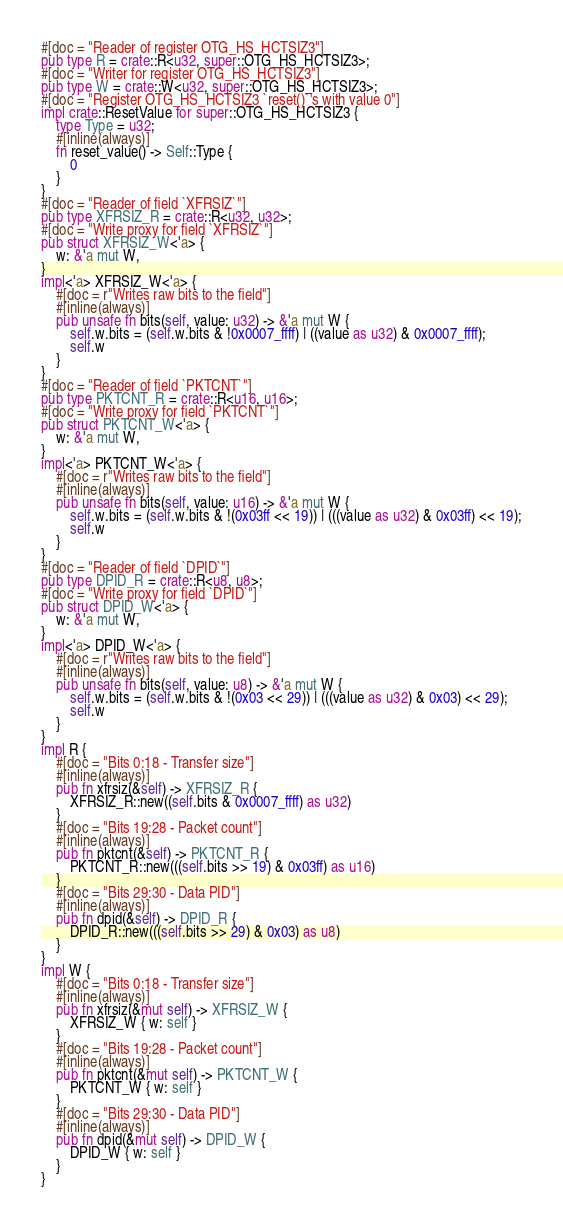<code> <loc_0><loc_0><loc_500><loc_500><_Rust_>#[doc = "Reader of register OTG_HS_HCTSIZ3"]
pub type R = crate::R<u32, super::OTG_HS_HCTSIZ3>;
#[doc = "Writer for register OTG_HS_HCTSIZ3"]
pub type W = crate::W<u32, super::OTG_HS_HCTSIZ3>;
#[doc = "Register OTG_HS_HCTSIZ3 `reset()`'s with value 0"]
impl crate::ResetValue for super::OTG_HS_HCTSIZ3 {
    type Type = u32;
    #[inline(always)]
    fn reset_value() -> Self::Type {
        0
    }
}
#[doc = "Reader of field `XFRSIZ`"]
pub type XFRSIZ_R = crate::R<u32, u32>;
#[doc = "Write proxy for field `XFRSIZ`"]
pub struct XFRSIZ_W<'a> {
    w: &'a mut W,
}
impl<'a> XFRSIZ_W<'a> {
    #[doc = r"Writes raw bits to the field"]
    #[inline(always)]
    pub unsafe fn bits(self, value: u32) -> &'a mut W {
        self.w.bits = (self.w.bits & !0x0007_ffff) | ((value as u32) & 0x0007_ffff);
        self.w
    }
}
#[doc = "Reader of field `PKTCNT`"]
pub type PKTCNT_R = crate::R<u16, u16>;
#[doc = "Write proxy for field `PKTCNT`"]
pub struct PKTCNT_W<'a> {
    w: &'a mut W,
}
impl<'a> PKTCNT_W<'a> {
    #[doc = r"Writes raw bits to the field"]
    #[inline(always)]
    pub unsafe fn bits(self, value: u16) -> &'a mut W {
        self.w.bits = (self.w.bits & !(0x03ff << 19)) | (((value as u32) & 0x03ff) << 19);
        self.w
    }
}
#[doc = "Reader of field `DPID`"]
pub type DPID_R = crate::R<u8, u8>;
#[doc = "Write proxy for field `DPID`"]
pub struct DPID_W<'a> {
    w: &'a mut W,
}
impl<'a> DPID_W<'a> {
    #[doc = r"Writes raw bits to the field"]
    #[inline(always)]
    pub unsafe fn bits(self, value: u8) -> &'a mut W {
        self.w.bits = (self.w.bits & !(0x03 << 29)) | (((value as u32) & 0x03) << 29);
        self.w
    }
}
impl R {
    #[doc = "Bits 0:18 - Transfer size"]
    #[inline(always)]
    pub fn xfrsiz(&self) -> XFRSIZ_R {
        XFRSIZ_R::new((self.bits & 0x0007_ffff) as u32)
    }
    #[doc = "Bits 19:28 - Packet count"]
    #[inline(always)]
    pub fn pktcnt(&self) -> PKTCNT_R {
        PKTCNT_R::new(((self.bits >> 19) & 0x03ff) as u16)
    }
    #[doc = "Bits 29:30 - Data PID"]
    #[inline(always)]
    pub fn dpid(&self) -> DPID_R {
        DPID_R::new(((self.bits >> 29) & 0x03) as u8)
    }
}
impl W {
    #[doc = "Bits 0:18 - Transfer size"]
    #[inline(always)]
    pub fn xfrsiz(&mut self) -> XFRSIZ_W {
        XFRSIZ_W { w: self }
    }
    #[doc = "Bits 19:28 - Packet count"]
    #[inline(always)]
    pub fn pktcnt(&mut self) -> PKTCNT_W {
        PKTCNT_W { w: self }
    }
    #[doc = "Bits 29:30 - Data PID"]
    #[inline(always)]
    pub fn dpid(&mut self) -> DPID_W {
        DPID_W { w: self }
    }
}
</code> 